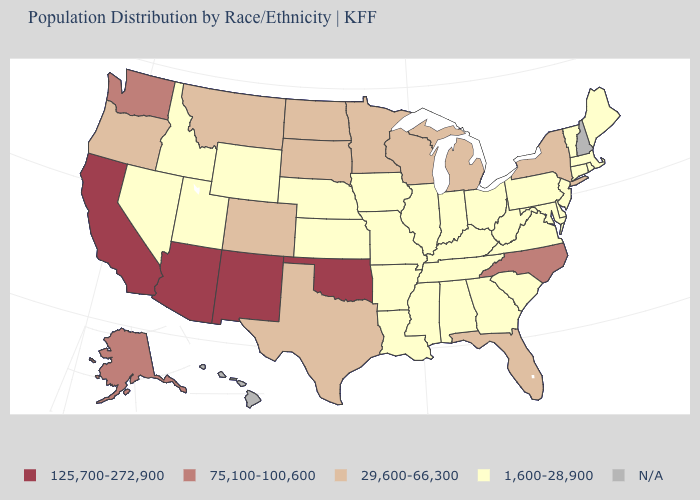Which states hav the highest value in the MidWest?
Short answer required. Michigan, Minnesota, North Dakota, South Dakota, Wisconsin. Which states have the lowest value in the USA?
Keep it brief. Alabama, Arkansas, Connecticut, Delaware, Georgia, Idaho, Illinois, Indiana, Iowa, Kansas, Kentucky, Louisiana, Maine, Maryland, Massachusetts, Mississippi, Missouri, Nebraska, Nevada, New Jersey, Ohio, Pennsylvania, Rhode Island, South Carolina, Tennessee, Utah, Vermont, Virginia, West Virginia, Wyoming. What is the value of Oklahoma?
Write a very short answer. 125,700-272,900. What is the value of Illinois?
Concise answer only. 1,600-28,900. What is the value of Wisconsin?
Be succinct. 29,600-66,300. What is the lowest value in the USA?
Concise answer only. 1,600-28,900. What is the value of Nebraska?
Be succinct. 1,600-28,900. What is the highest value in states that border Georgia?
Give a very brief answer. 75,100-100,600. What is the value of Delaware?
Concise answer only. 1,600-28,900. Does North Dakota have the lowest value in the MidWest?
Be succinct. No. What is the value of Maryland?
Concise answer only. 1,600-28,900. Name the states that have a value in the range 1,600-28,900?
Short answer required. Alabama, Arkansas, Connecticut, Delaware, Georgia, Idaho, Illinois, Indiana, Iowa, Kansas, Kentucky, Louisiana, Maine, Maryland, Massachusetts, Mississippi, Missouri, Nebraska, Nevada, New Jersey, Ohio, Pennsylvania, Rhode Island, South Carolina, Tennessee, Utah, Vermont, Virginia, West Virginia, Wyoming. What is the value of Alaska?
Give a very brief answer. 75,100-100,600. What is the value of Indiana?
Answer briefly. 1,600-28,900. Does Washington have the highest value in the West?
Write a very short answer. No. 